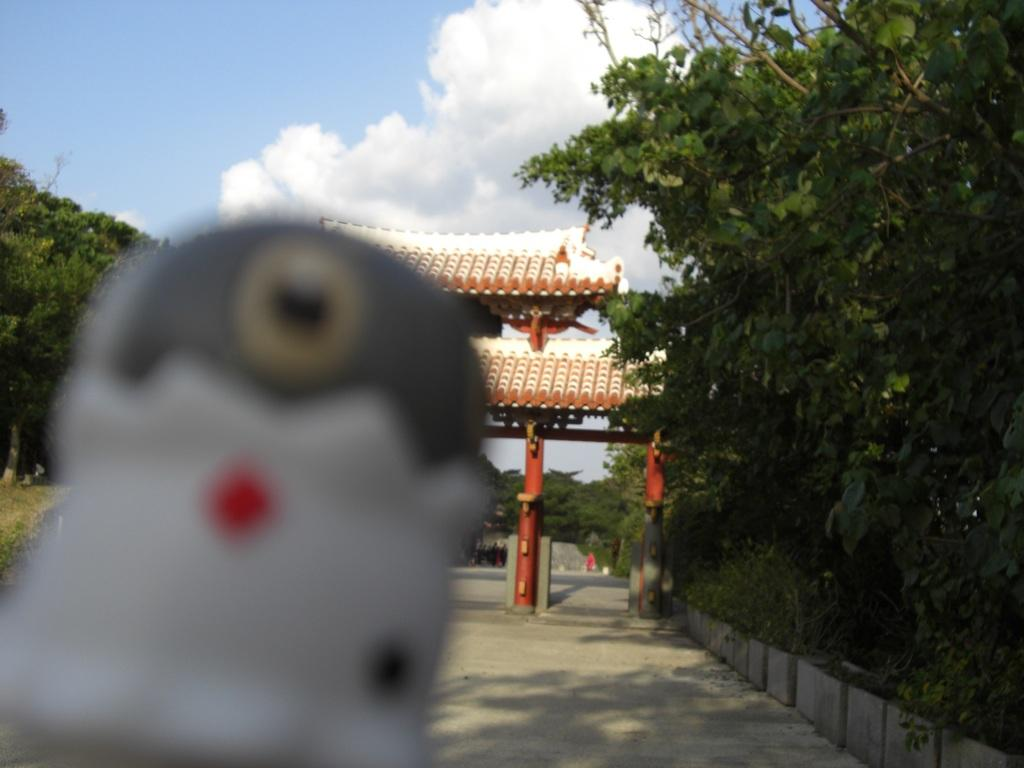What is the blurred object in the image? Unfortunately, the facts provided do not give enough information to determine what the blurred object is. What can be seen running through the image? There is a road in the image. What architectural feature is present in the image? There is an arch in the image. What type of vegetation is present on either side of the image? Trees are present on either side of the image. What is visible in the background of the image? The sky is visible in the background of the image. What can be seen in the sky in the image? Clouds are present in the sky. Where is the vase located in the image? There is no vase present in the image. Can you describe the trail that runs through the image? There is no trail present in the image; it features a road instead. 